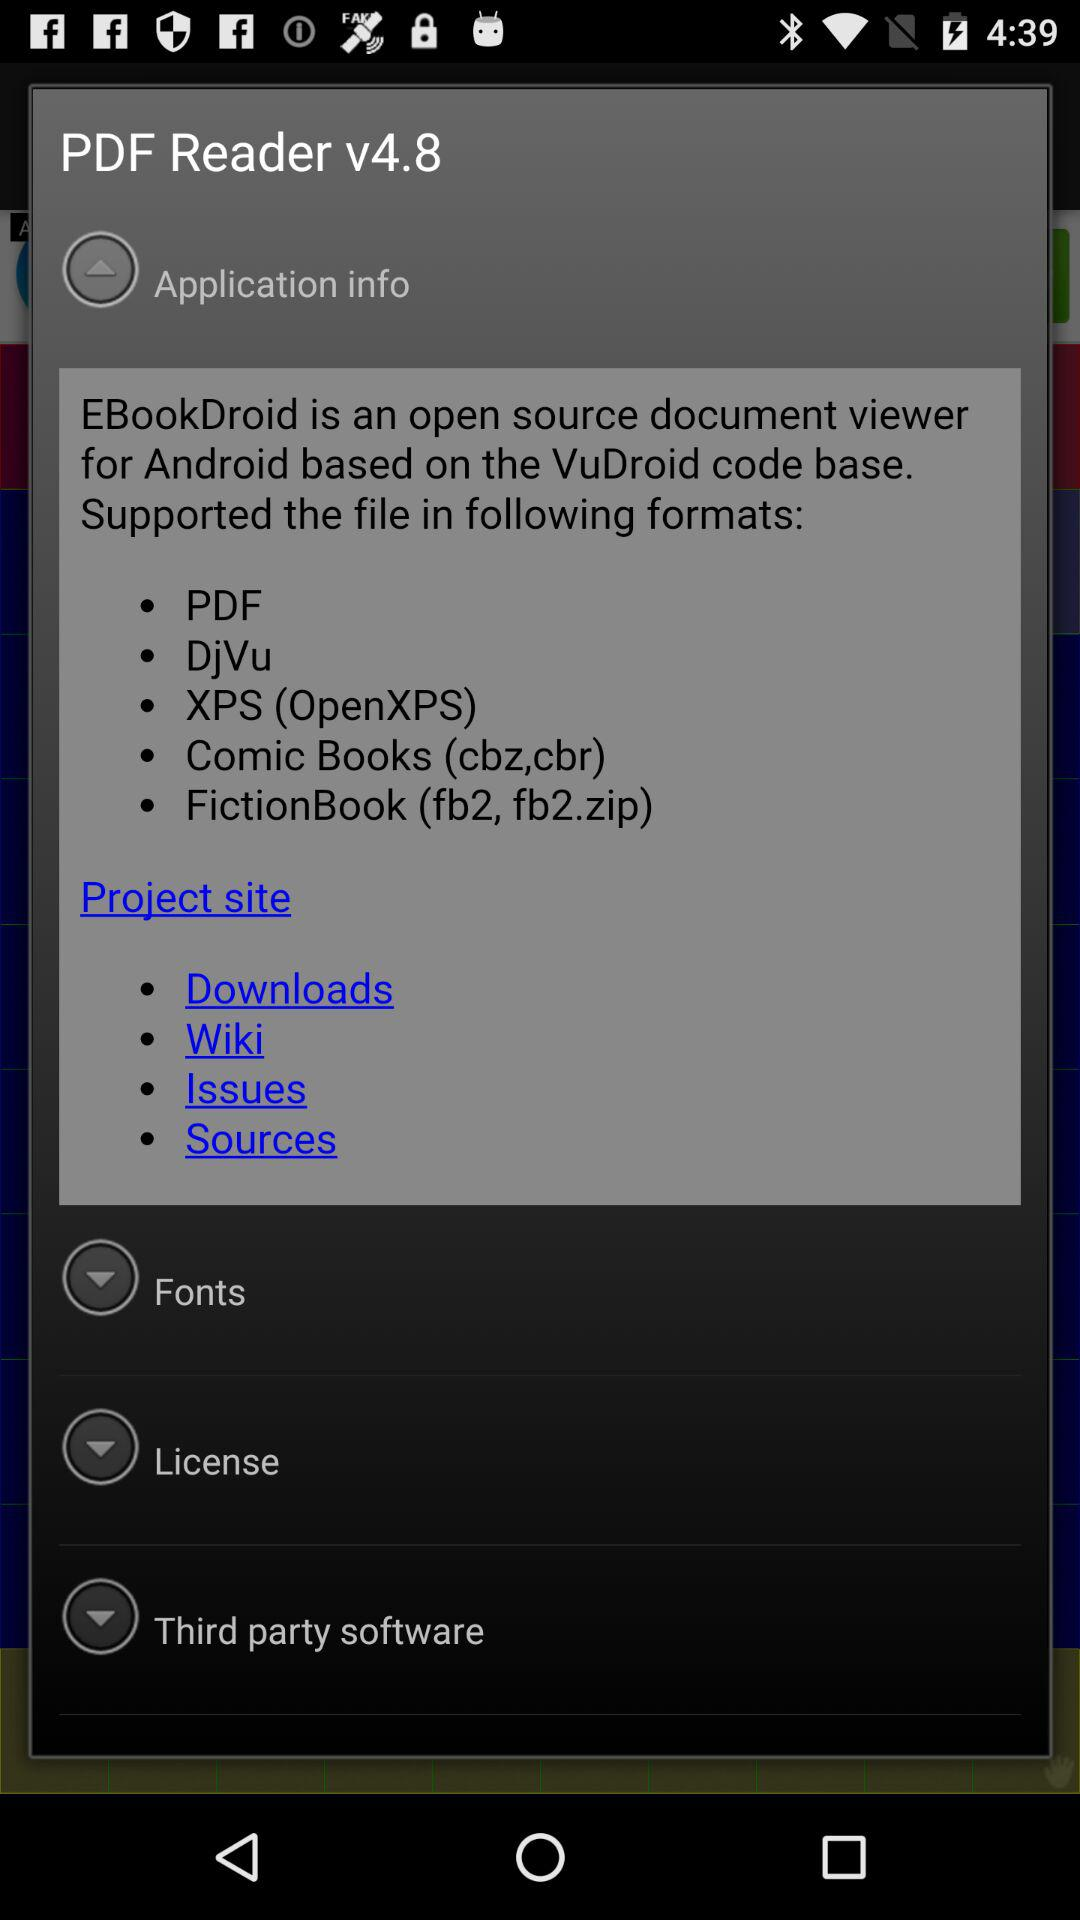What is the project website for "PDF Reader"?
When the provided information is insufficient, respond with <no answer>. <no answer> 